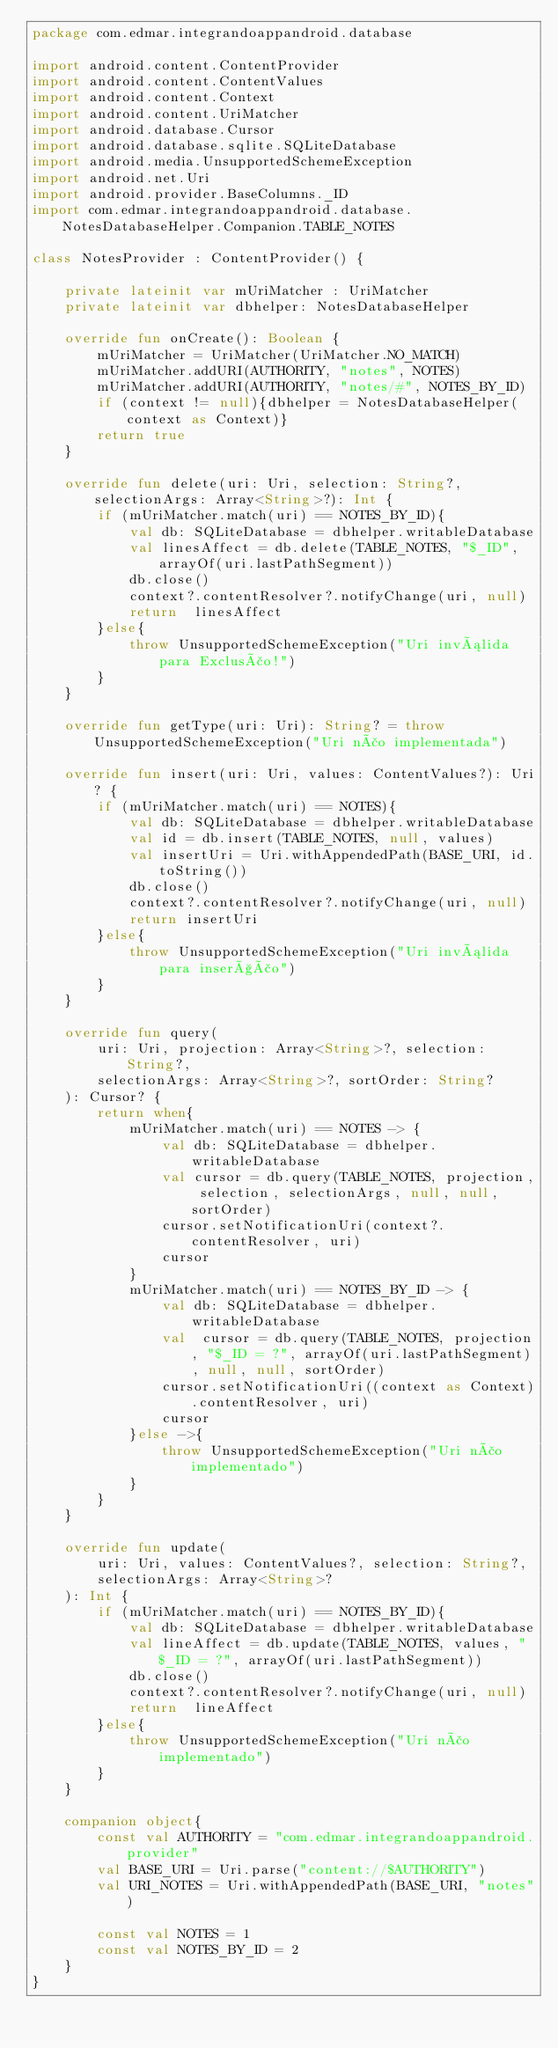Convert code to text. <code><loc_0><loc_0><loc_500><loc_500><_Kotlin_>package com.edmar.integrandoappandroid.database

import android.content.ContentProvider
import android.content.ContentValues
import android.content.Context
import android.content.UriMatcher
import android.database.Cursor
import android.database.sqlite.SQLiteDatabase
import android.media.UnsupportedSchemeException
import android.net.Uri
import android.provider.BaseColumns._ID
import com.edmar.integrandoappandroid.database.NotesDatabaseHelper.Companion.TABLE_NOTES

class NotesProvider : ContentProvider() {

    private lateinit var mUriMatcher : UriMatcher
    private lateinit var dbhelper: NotesDatabaseHelper

    override fun onCreate(): Boolean {
        mUriMatcher = UriMatcher(UriMatcher.NO_MATCH)
        mUriMatcher.addURI(AUTHORITY, "notes", NOTES)
        mUriMatcher.addURI(AUTHORITY, "notes/#", NOTES_BY_ID)
        if (context != null){dbhelper = NotesDatabaseHelper(context as Context)}
        return true
    }

    override fun delete(uri: Uri, selection: String?, selectionArgs: Array<String>?): Int {
        if (mUriMatcher.match(uri) == NOTES_BY_ID){
            val db: SQLiteDatabase = dbhelper.writableDatabase
            val linesAffect = db.delete(TABLE_NOTES, "$_ID", arrayOf(uri.lastPathSegment))
            db.close()
            context?.contentResolver?.notifyChange(uri, null)
            return  linesAffect
        }else{
            throw UnsupportedSchemeException("Uri inválida para Exclusão!")
        }
    }

    override fun getType(uri: Uri): String? = throw  UnsupportedSchemeException("Uri não implementada")

    override fun insert(uri: Uri, values: ContentValues?): Uri? {
        if (mUriMatcher.match(uri) == NOTES){
            val db: SQLiteDatabase = dbhelper.writableDatabase
            val id = db.insert(TABLE_NOTES, null, values)
            val insertUri = Uri.withAppendedPath(BASE_URI, id.toString())
            db.close()
            context?.contentResolver?.notifyChange(uri, null)
            return insertUri
        }else{
            throw UnsupportedSchemeException("Uri inválida para inserção")
        }
    }

    override fun query(
        uri: Uri, projection: Array<String>?, selection: String?,
        selectionArgs: Array<String>?, sortOrder: String?
    ): Cursor? {
        return when{
            mUriMatcher.match(uri) == NOTES -> {
                val db: SQLiteDatabase = dbhelper.writableDatabase
                val cursor = db.query(TABLE_NOTES, projection, selection, selectionArgs, null, null, sortOrder)
                cursor.setNotificationUri(context?.contentResolver, uri)
                cursor
            }
            mUriMatcher.match(uri) == NOTES_BY_ID -> {
                val db: SQLiteDatabase = dbhelper.writableDatabase
                val  cursor = db.query(TABLE_NOTES, projection, "$_ID = ?", arrayOf(uri.lastPathSegment), null, null, sortOrder)
                cursor.setNotificationUri((context as Context).contentResolver, uri)
                cursor
            }else ->{
                throw UnsupportedSchemeException("Uri não implementado")
            }
        }
    }

    override fun update(
        uri: Uri, values: ContentValues?, selection: String?,
        selectionArgs: Array<String>?
    ): Int {
        if (mUriMatcher.match(uri) == NOTES_BY_ID){
            val db: SQLiteDatabase = dbhelper.writableDatabase
            val lineAffect = db.update(TABLE_NOTES, values, "$_ID = ?", arrayOf(uri.lastPathSegment))
            db.close()
            context?.contentResolver?.notifyChange(uri, null)
            return  lineAffect
        }else{
            throw UnsupportedSchemeException("Uri não implementado")
        }
    }

    companion object{
        const val AUTHORITY = "com.edmar.integrandoappandroid.provider"
        val BASE_URI = Uri.parse("content://$AUTHORITY")
        val URI_NOTES = Uri.withAppendedPath(BASE_URI, "notes")

        const val NOTES = 1
        const val NOTES_BY_ID = 2
    }
}</code> 